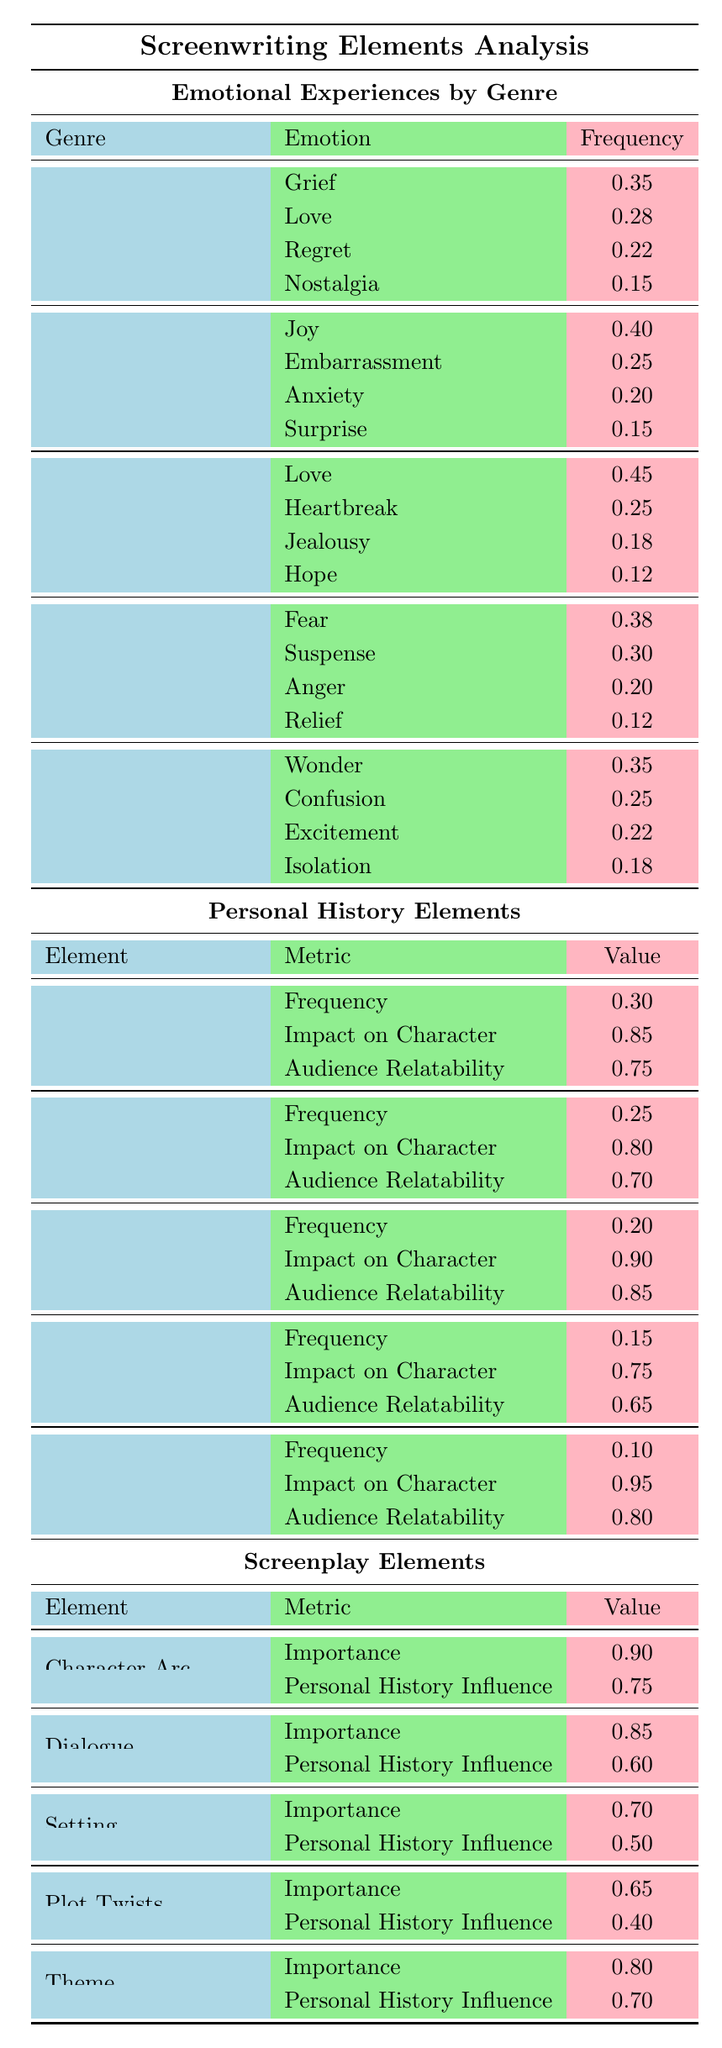What is the most frequently used emotional experience in Drama? In the Drama genre, the emotional experiences listed are Grief (0.35), Love (0.28), Regret (0.22), and Nostalgia (0.15). The highest frequency is Grief at 0.35.
Answer: Grief Which emotional experience is least used in Romance? The emotional experiences for Romance are Love (0.45), Heartbreak (0.25), Jealousy (0.18), and Hope (0.12). The lowest value is for Hope at 0.12.
Answer: Hope Is Fear more common in Thrillers than Joy in Comedies? Fear in Thriller has a frequency of 0.38, while Joy in Comedy has a frequency of 0.40. Since 0.38 is less than 0.40, Fear is not more common.
Answer: No What is the average frequency of emotional experiences in Sci-Fi? The emotional experiences in Sci-Fi are Wonder (0.35), Confusion (0.25), Excitement (0.22), and Isolation (0.18). The sum is (0.35 + 0.25 + 0.22 + 0.18) = 1.00. With 4 experiences, the average is 1.00 / 4 = 0.25.
Answer: 0.25 Which emotional experience has the highest impact on character development according to Personal History Elements? The highest impact noted in Personal History Elements is for Personal Loss at 0.95, followed by Family Dynamics at 0.90, and Childhood Memories at 0.85. Hence, Personal Loss has the highest impact.
Answer: Personal Loss Total emotional experience frequency for Comedy? The emotional experiences in Comedy are Joy (0.40), Embarrassment (0.25), Anxiety (0.20), and Surprise (0.15). The total frequency sums to (0.40 + 0.25 + 0.20 + 0.15) = 1.00.
Answer: 1.00 Is the audience relatability for Childhood Memories greater than for Career Struggles? The audience relatability for Childhood Memories is 0.75, while for Career Struggles it is 0.65. Since 0.75 is greater than 0.65, the statement is true.
Answer: Yes What is the significance of the Character Arc in screenplay elements? The Character Arc has an importance score of 0.90, which is the highest among screenplay elements.
Answer: 0.90 Does the impact of Family Dynamics on character development surpass that of First Love? Family Dynamics has an impact of 0.90, while First Love has an impact of 0.80. Since 0.90 is greater than 0.80, Family Dynamics has a greater impact.
Answer: Yes What percentage of emotional experiences in Drama focus on Love? In Drama, Love has a frequency of 0.28, which accounts for 28% of the total emotional experiences in that genre.
Answer: 28% 